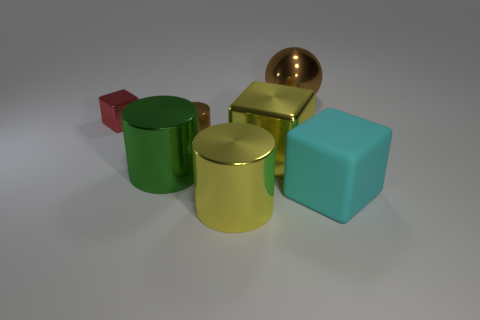The big object to the left of the large cylinder on the right side of the small metal object right of the tiny red shiny thing is what color?
Provide a succinct answer. Green. There is a yellow shiny block; does it have the same size as the yellow metal cylinder that is right of the tiny red object?
Make the answer very short. Yes. How many objects are either small red objects or big green metal cylinders?
Give a very brief answer. 2. Is there a yellow cylinder made of the same material as the big sphere?
Offer a very short reply. Yes. What size is the object that is the same color as the large shiny ball?
Give a very brief answer. Small. What color is the big metal object that is in front of the big cube to the right of the big yellow cube?
Make the answer very short. Yellow. Does the cyan object have the same size as the red metallic cube?
Make the answer very short. No. How many cubes are either big objects or big green metallic objects?
Your response must be concise. 2. How many cylinders are left of the small object in front of the tiny red metallic cube?
Provide a short and direct response. 1. Do the tiny red thing and the green metal thing have the same shape?
Your response must be concise. No. 